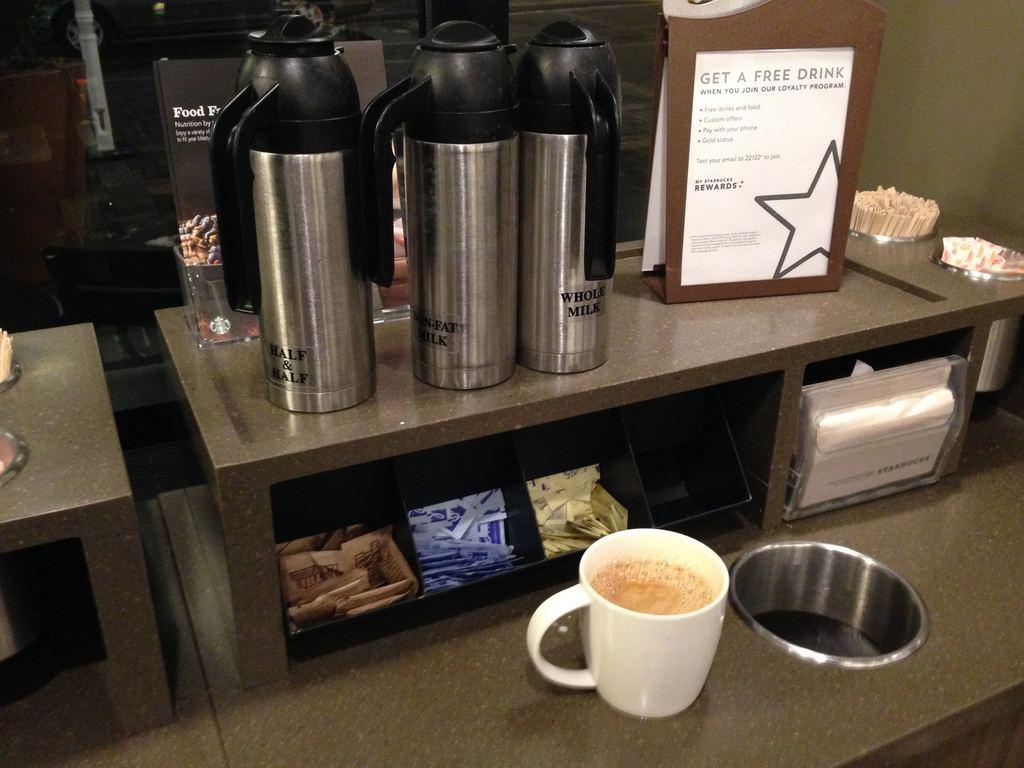<image>
Offer a succinct explanation of the picture presented. a coffee shop milk and sugar bar with sign reading Get a Free Drink 